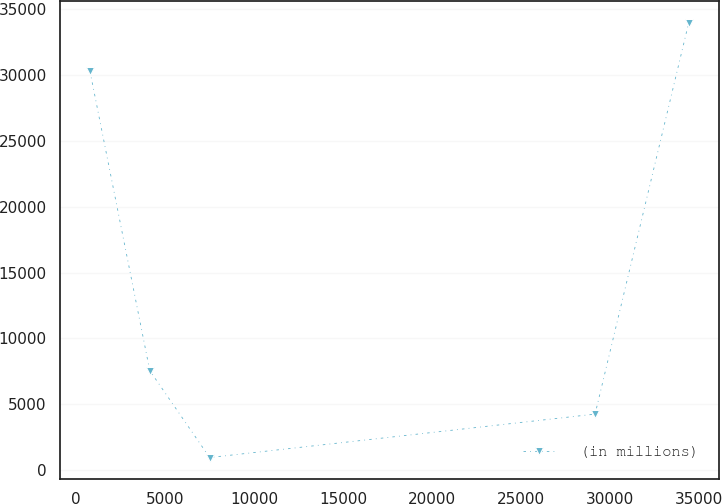<chart> <loc_0><loc_0><loc_500><loc_500><line_chart><ecel><fcel>(in millions)<nl><fcel>780.16<fcel>30316.8<nl><fcel>4143.65<fcel>7557.44<nl><fcel>7507.14<fcel>958.2<nl><fcel>29159.6<fcel>4257.82<nl><fcel>34415<fcel>33954.4<nl></chart> 